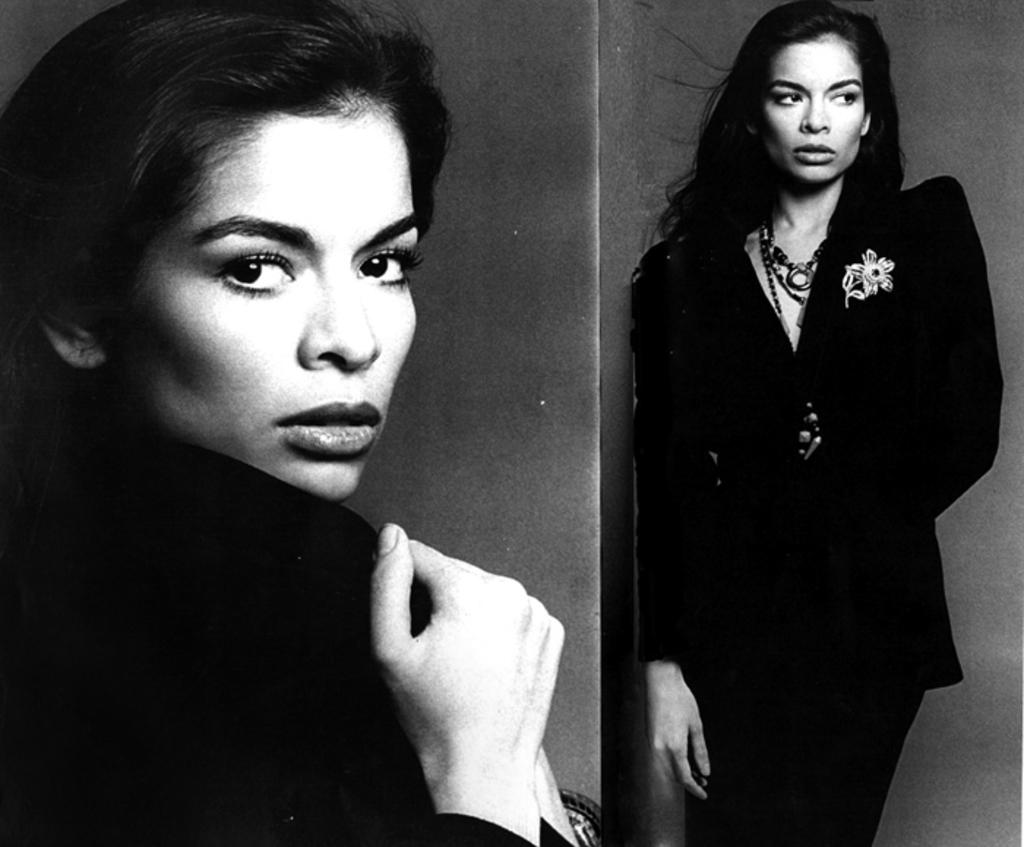What is the style of the image in the collage? The image is a black and white collage. What type of image can be found in the collage? The collage contains an image of a woman. How are the images of the woman presented in the collage? The left side of the collage has a zoomed-in image of the woman, while the right side has the full image of the woman. What type of bomb is depicted in the collage? There is no bomb present in the collage; it features an image of a woman. How many crows are visible in the collage? There are no crows present in the collage; it only contains an image of a woman. 